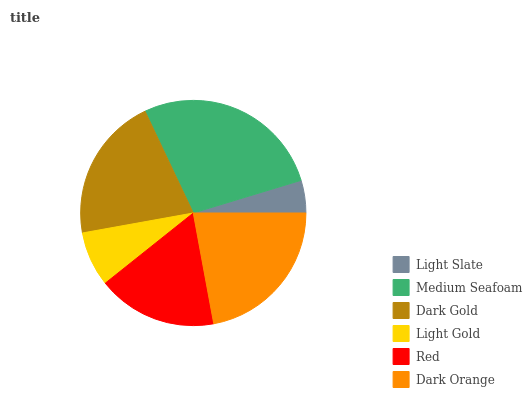Is Light Slate the minimum?
Answer yes or no. Yes. Is Medium Seafoam the maximum?
Answer yes or no. Yes. Is Dark Gold the minimum?
Answer yes or no. No. Is Dark Gold the maximum?
Answer yes or no. No. Is Medium Seafoam greater than Dark Gold?
Answer yes or no. Yes. Is Dark Gold less than Medium Seafoam?
Answer yes or no. Yes. Is Dark Gold greater than Medium Seafoam?
Answer yes or no. No. Is Medium Seafoam less than Dark Gold?
Answer yes or no. No. Is Dark Gold the high median?
Answer yes or no. Yes. Is Red the low median?
Answer yes or no. Yes. Is Dark Orange the high median?
Answer yes or no. No. Is Light Slate the low median?
Answer yes or no. No. 